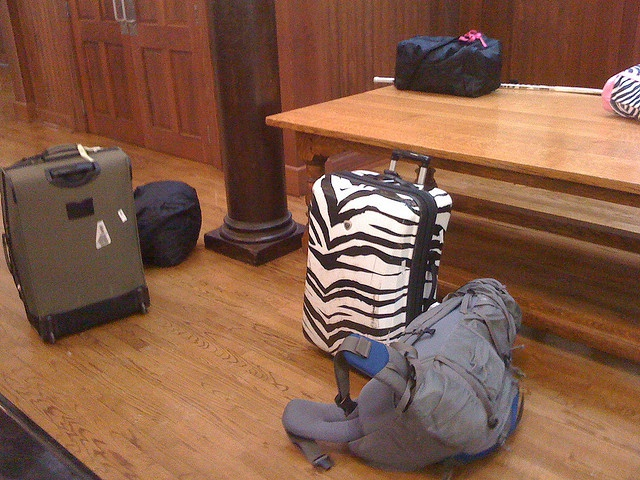Describe the objects in this image and their specific colors. I can see backpack in maroon and gray tones, dining table in maroon, tan, and brown tones, suitcase in maroon, gray, and black tones, and suitcase in maroon, white, black, and gray tones in this image. 